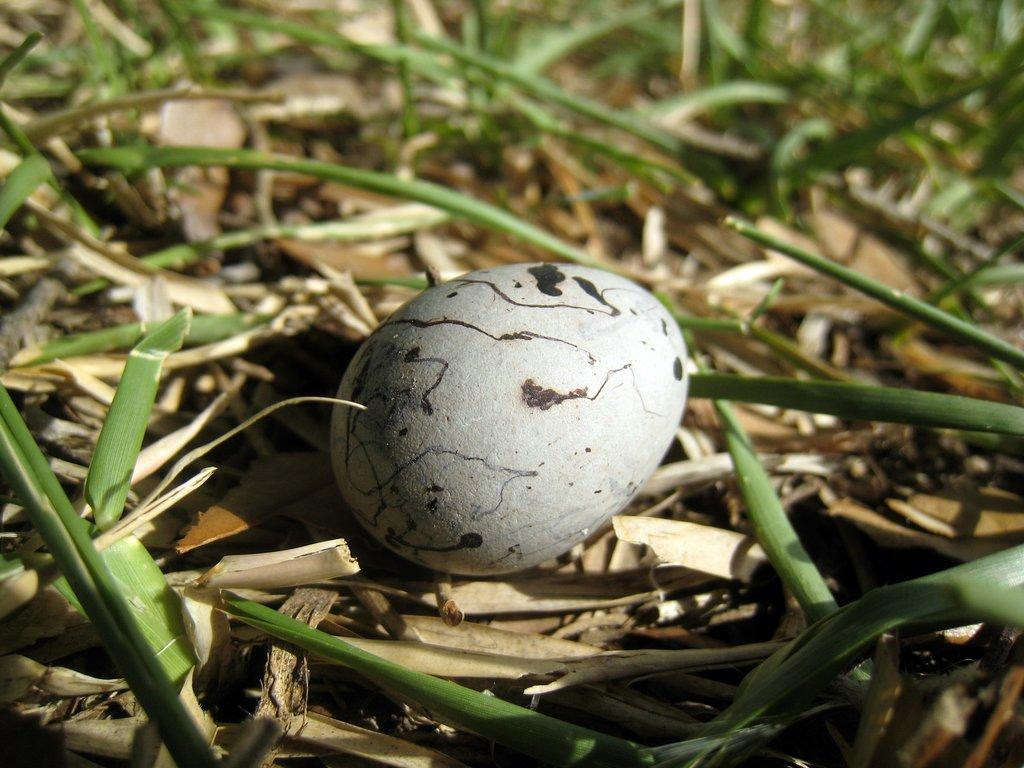What object is placed on the ground in the image? There is an egg placed on the ground. What can be seen in the background of the image? There are leaves visible in the background of the image. What color is the crayon used to draw on the egg in the image? There is no crayon or drawing present on the egg in the image. What does the egg smell like in the image? The image does not provide information about the smell of the egg. 